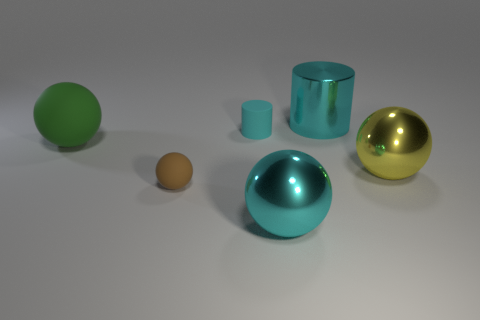Add 2 big cyan objects. How many objects exist? 8 Subtract all spheres. How many objects are left? 2 Subtract all big cyan balls. Subtract all large brown shiny things. How many objects are left? 5 Add 5 cyan metallic cylinders. How many cyan metallic cylinders are left? 6 Add 3 brown metallic cubes. How many brown metallic cubes exist? 3 Subtract 1 yellow balls. How many objects are left? 5 